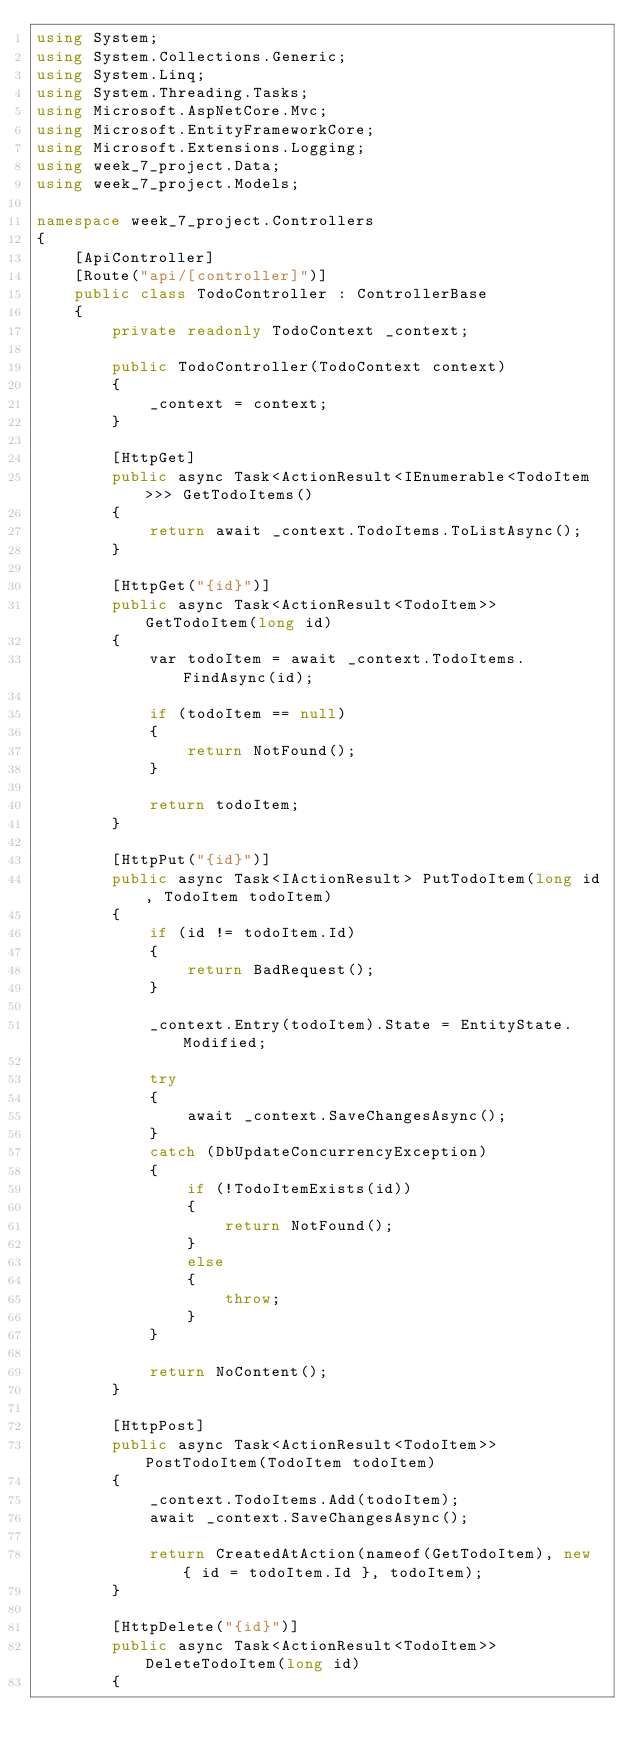<code> <loc_0><loc_0><loc_500><loc_500><_C#_>using System;
using System.Collections.Generic;
using System.Linq;
using System.Threading.Tasks;
using Microsoft.AspNetCore.Mvc;
using Microsoft.EntityFrameworkCore;
using Microsoft.Extensions.Logging;
using week_7_project.Data;
using week_7_project.Models;

namespace week_7_project.Controllers
{
    [ApiController]
    [Route("api/[controller]")]
    public class TodoController : ControllerBase
    {
        private readonly TodoContext _context;

        public TodoController(TodoContext context)
        {
            _context = context;
        }

        [HttpGet]
        public async Task<ActionResult<IEnumerable<TodoItem>>> GetTodoItems()
        {
            return await _context.TodoItems.ToListAsync();
        }

        [HttpGet("{id}")]
        public async Task<ActionResult<TodoItem>> GetTodoItem(long id)
        {
            var todoItem = await _context.TodoItems.FindAsync(id);

            if (todoItem == null)
            {
                return NotFound();
            }

            return todoItem;
        }

        [HttpPut("{id}")]
        public async Task<IActionResult> PutTodoItem(long id, TodoItem todoItem)
        {
            if (id != todoItem.Id)
            {
                return BadRequest();
            }

            _context.Entry(todoItem).State = EntityState.Modified;

            try
            {
                await _context.SaveChangesAsync();
            }
            catch (DbUpdateConcurrencyException)
            {
                if (!TodoItemExists(id))
                {
                    return NotFound();
                }
                else
                {
                    throw;
                }
            }

            return NoContent();
        }

        [HttpPost]
        public async Task<ActionResult<TodoItem>> PostTodoItem(TodoItem todoItem)
        {
            _context.TodoItems.Add(todoItem);
            await _context.SaveChangesAsync();

            return CreatedAtAction(nameof(GetTodoItem), new { id = todoItem.Id }, todoItem);
        }

        [HttpDelete("{id}")]
        public async Task<ActionResult<TodoItem>> DeleteTodoItem(long id)
        {</code> 